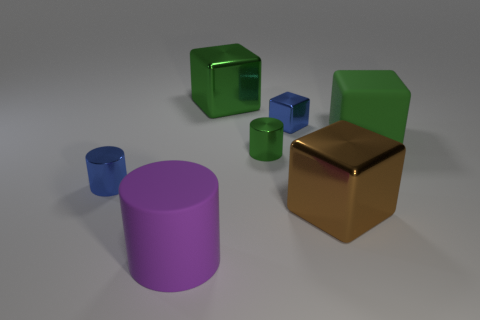How many large purple rubber objects are there? There is one large purple rubber object in the image, which is a cylindrical shape. 